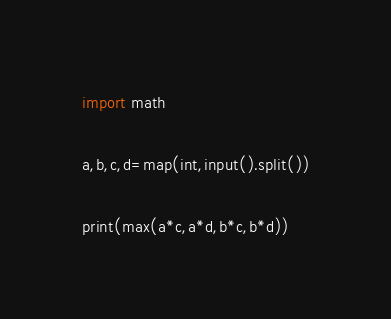<code> <loc_0><loc_0><loc_500><loc_500><_Python_>import math

a,b,c,d=map(int,input().split())

print(max(a*c,a*d,b*c,b*d))</code> 